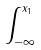Convert formula to latex. <formula><loc_0><loc_0><loc_500><loc_500>\int _ { - \infty } ^ { x _ { 1 } }</formula> 